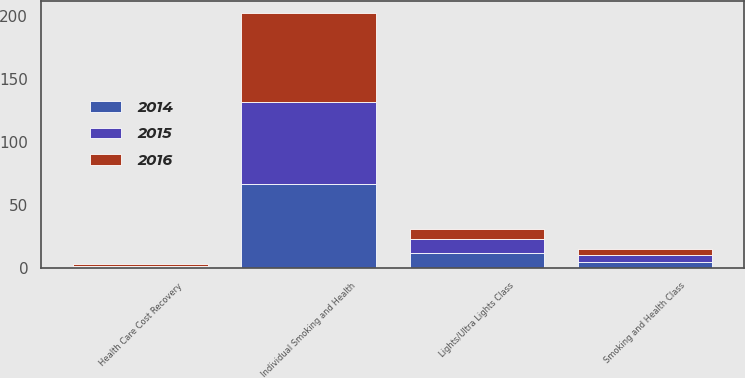<chart> <loc_0><loc_0><loc_500><loc_500><stacked_bar_chart><ecel><fcel>Individual Smoking and Health<fcel>Smoking and Health Class<fcel>Health Care Cost Recovery<fcel>Lights/Ultra Lights Class<nl><fcel>2016<fcel>70<fcel>5<fcel>1<fcel>8<nl><fcel>2015<fcel>65<fcel>5<fcel>1<fcel>11<nl><fcel>2014<fcel>67<fcel>5<fcel>1<fcel>12<nl></chart> 